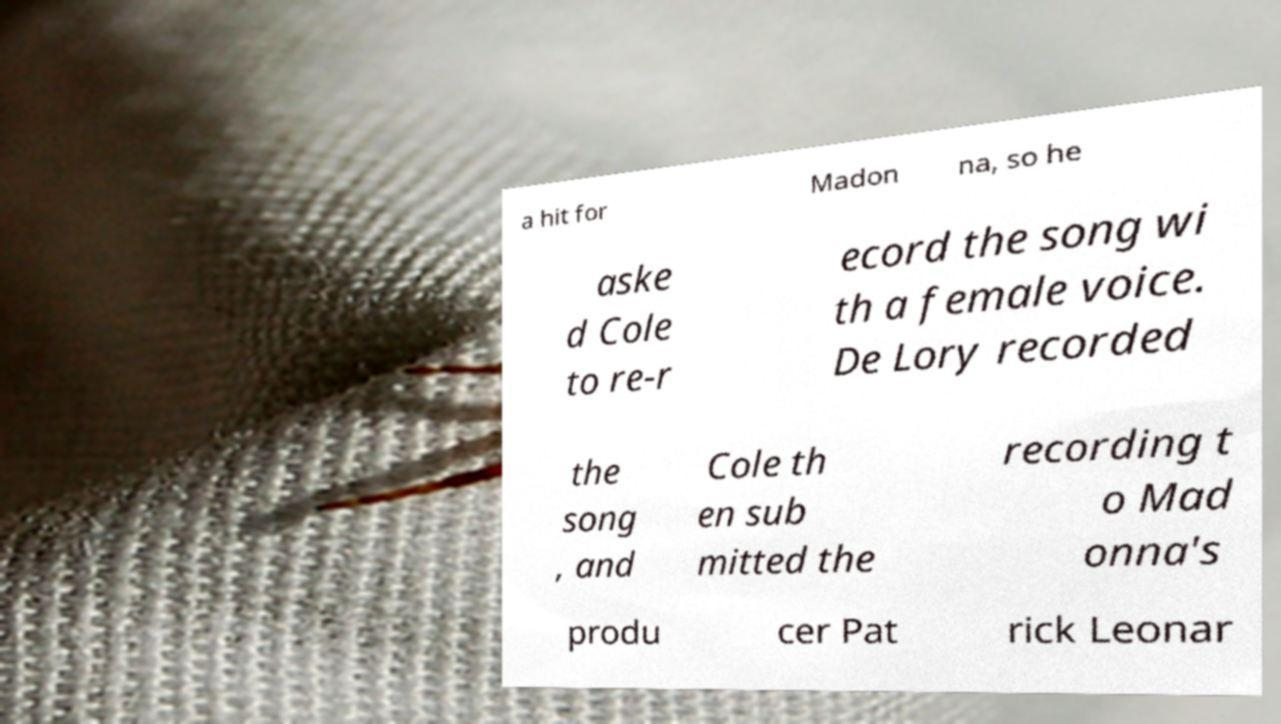Please read and relay the text visible in this image. What does it say? a hit for Madon na, so he aske d Cole to re-r ecord the song wi th a female voice. De Lory recorded the song , and Cole th en sub mitted the recording t o Mad onna's produ cer Pat rick Leonar 